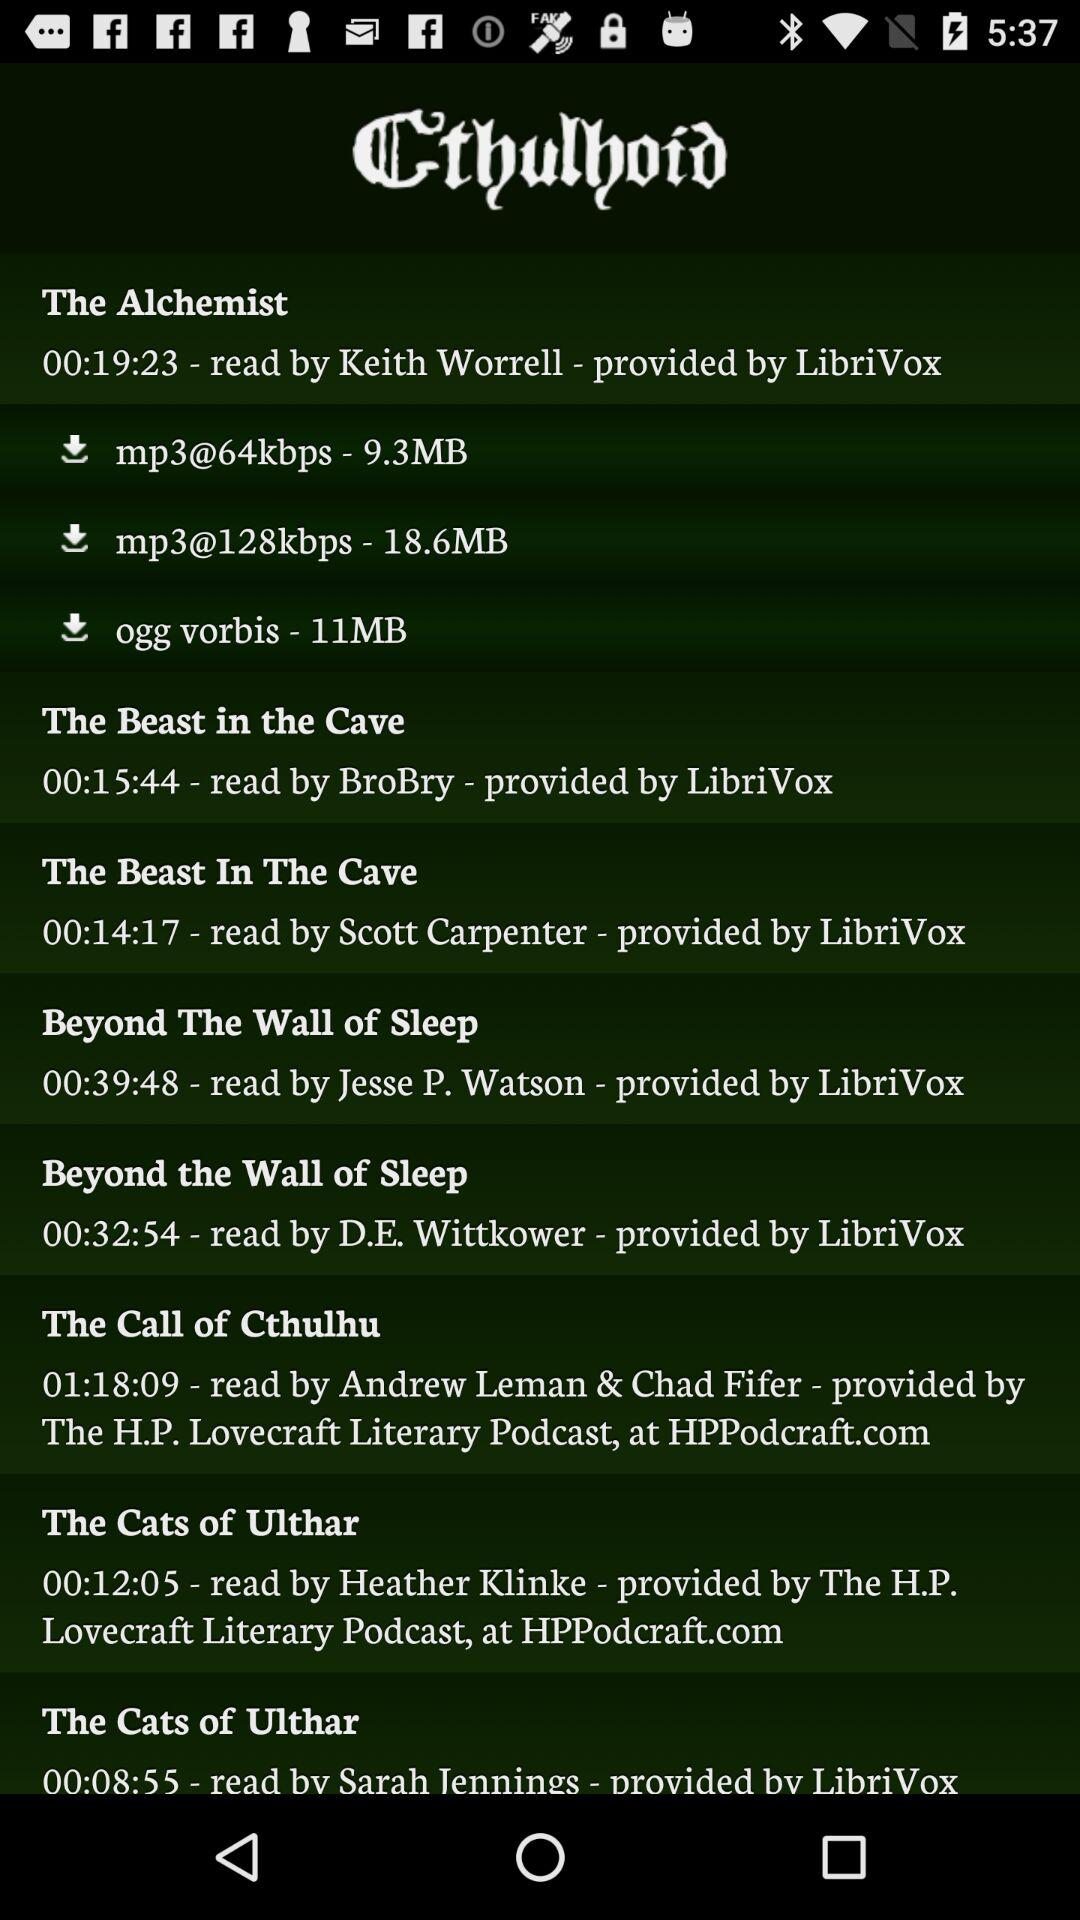What is the size of the file "ogg vorbis"? The size of the file "ogg vorbis" is 11 MB. 